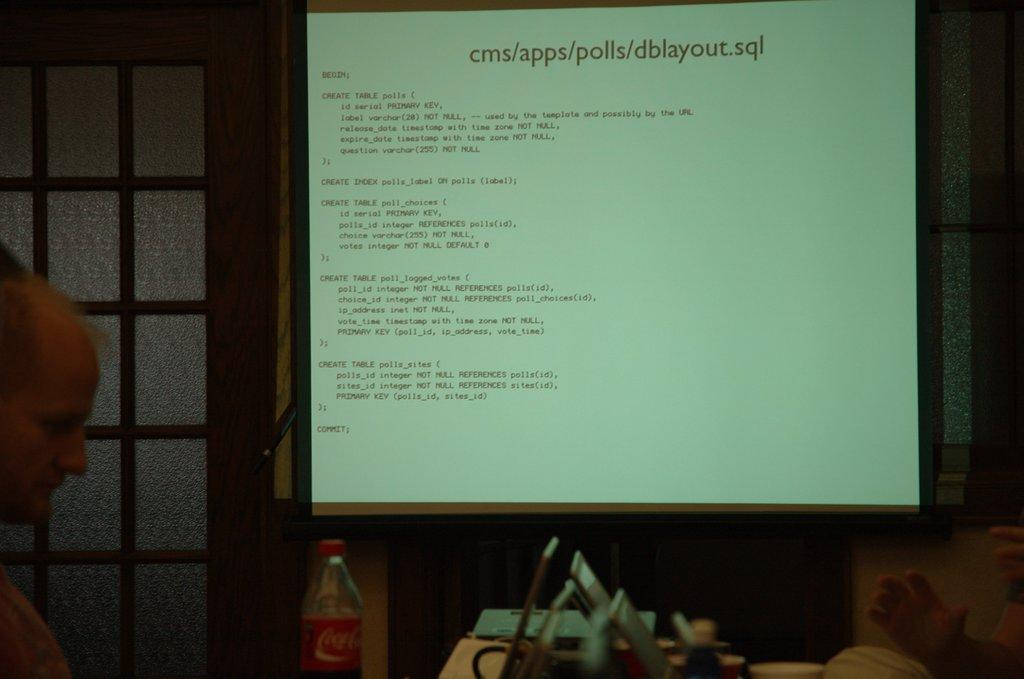Provide a one-sentence caption for the provided image. The source code for dblayout.sql being projected onto a large screen. 